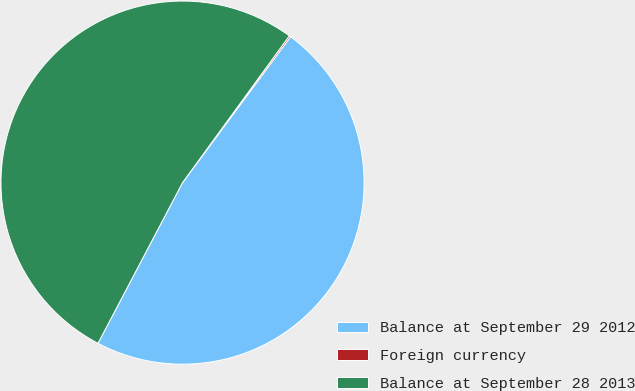Convert chart to OTSL. <chart><loc_0><loc_0><loc_500><loc_500><pie_chart><fcel>Balance at September 29 2012<fcel>Foreign currency<fcel>Balance at September 28 2013<nl><fcel>47.56%<fcel>0.14%<fcel>52.3%<nl></chart> 